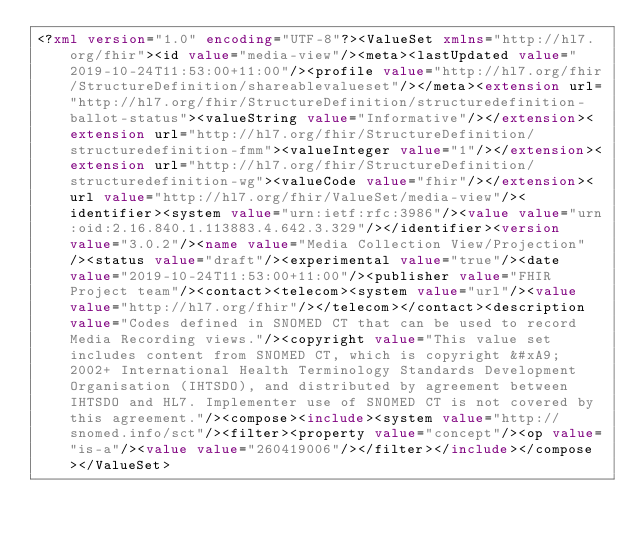<code> <loc_0><loc_0><loc_500><loc_500><_XML_><?xml version="1.0" encoding="UTF-8"?><ValueSet xmlns="http://hl7.org/fhir"><id value="media-view"/><meta><lastUpdated value="2019-10-24T11:53:00+11:00"/><profile value="http://hl7.org/fhir/StructureDefinition/shareablevalueset"/></meta><extension url="http://hl7.org/fhir/StructureDefinition/structuredefinition-ballot-status"><valueString value="Informative"/></extension><extension url="http://hl7.org/fhir/StructureDefinition/structuredefinition-fmm"><valueInteger value="1"/></extension><extension url="http://hl7.org/fhir/StructureDefinition/structuredefinition-wg"><valueCode value="fhir"/></extension><url value="http://hl7.org/fhir/ValueSet/media-view"/><identifier><system value="urn:ietf:rfc:3986"/><value value="urn:oid:2.16.840.1.113883.4.642.3.329"/></identifier><version value="3.0.2"/><name value="Media Collection View/Projection"/><status value="draft"/><experimental value="true"/><date value="2019-10-24T11:53:00+11:00"/><publisher value="FHIR Project team"/><contact><telecom><system value="url"/><value value="http://hl7.org/fhir"/></telecom></contact><description value="Codes defined in SNOMED CT that can be used to record Media Recording views."/><copyright value="This value set includes content from SNOMED CT, which is copyright &#xA9; 2002+ International Health Terminology Standards Development Organisation (IHTSDO), and distributed by agreement between IHTSDO and HL7. Implementer use of SNOMED CT is not covered by this agreement."/><compose><include><system value="http://snomed.info/sct"/><filter><property value="concept"/><op value="is-a"/><value value="260419006"/></filter></include></compose></ValueSet></code> 